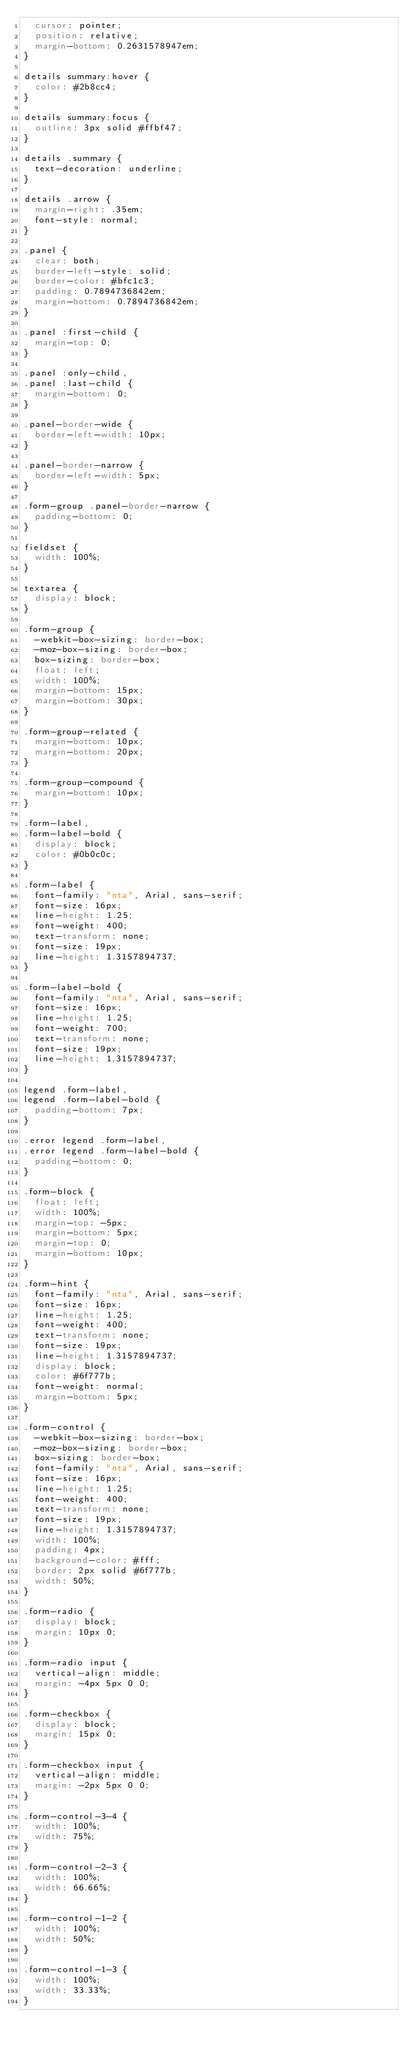<code> <loc_0><loc_0><loc_500><loc_500><_CSS_>  cursor: pointer;
  position: relative;
  margin-bottom: 0.2631578947em;
}

details summary:hover {
  color: #2b8cc4;
}

details summary:focus {
  outline: 3px solid #ffbf47;
}

details .summary {
  text-decoration: underline;
}

details .arrow {
  margin-right: .35em;
  font-style: normal;
}

.panel {
  clear: both;
  border-left-style: solid;
  border-color: #bfc1c3;
  padding: 0.7894736842em;
  margin-bottom: 0.7894736842em;
}

.panel :first-child {
  margin-top: 0;
}

.panel :only-child,
.panel :last-child {
  margin-bottom: 0;
}

.panel-border-wide {
  border-left-width: 10px;
}

.panel-border-narrow {
  border-left-width: 5px;
}

.form-group .panel-border-narrow {
  padding-bottom: 0;
}

fieldset {
  width: 100%;
}

textarea {
  display: block;
}

.form-group {
  -webkit-box-sizing: border-box;
  -moz-box-sizing: border-box;
  box-sizing: border-box;
  float: left;
  width: 100%;
  margin-bottom: 15px;
  margin-bottom: 30px;
}

.form-group-related {
  margin-bottom: 10px;
  margin-bottom: 20px;
}

.form-group-compound {
  margin-bottom: 10px;
}

.form-label,
.form-label-bold {
  display: block;
  color: #0b0c0c;
}

.form-label {
  font-family: "nta", Arial, sans-serif;
  font-size: 16px;
  line-height: 1.25;
  font-weight: 400;
  text-transform: none;
  font-size: 19px;
  line-height: 1.3157894737;
}

.form-label-bold {
  font-family: "nta", Arial, sans-serif;
  font-size: 16px;
  line-height: 1.25;
  font-weight: 700;
  text-transform: none;
  font-size: 19px;
  line-height: 1.3157894737;
}

legend .form-label,
legend .form-label-bold {
  padding-bottom: 7px;
}

.error legend .form-label,
.error legend .form-label-bold {
  padding-bottom: 0;
}

.form-block {
  float: left;
  width: 100%;
  margin-top: -5px;
  margin-bottom: 5px;
  margin-top: 0;
  margin-bottom: 10px;
}

.form-hint {
  font-family: "nta", Arial, sans-serif;
  font-size: 16px;
  line-height: 1.25;
  font-weight: 400;
  text-transform: none;
  font-size: 19px;
  line-height: 1.3157894737;
  display: block;
  color: #6f777b;
  font-weight: normal;
  margin-bottom: 5px;
}

.form-control {
  -webkit-box-sizing: border-box;
  -moz-box-sizing: border-box;
  box-sizing: border-box;
  font-family: "nta", Arial, sans-serif;
  font-size: 16px;
  line-height: 1.25;
  font-weight: 400;
  text-transform: none;
  font-size: 19px;
  line-height: 1.3157894737;
  width: 100%;
  padding: 4px;
  background-color: #fff;
  border: 2px solid #6f777b;
  width: 50%;
}

.form-radio {
  display: block;
  margin: 10px 0;
}

.form-radio input {
  vertical-align: middle;
  margin: -4px 5px 0 0;
}

.form-checkbox {
  display: block;
  margin: 15px 0;
}

.form-checkbox input {
  vertical-align: middle;
  margin: -2px 5px 0 0;
}

.form-control-3-4 {
  width: 100%;
  width: 75%;
}

.form-control-2-3 {
  width: 100%;
  width: 66.66%;
}

.form-control-1-2 {
  width: 100%;
  width: 50%;
}

.form-control-1-3 {
  width: 100%;
  width: 33.33%;
}
</code> 